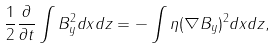Convert formula to latex. <formula><loc_0><loc_0><loc_500><loc_500>\frac { 1 } { 2 } \frac { \partial } { \partial t } \int B _ { y } ^ { 2 } d x d z = - \int \eta ( \nabla B _ { y } ) ^ { 2 } d x d z ,</formula> 